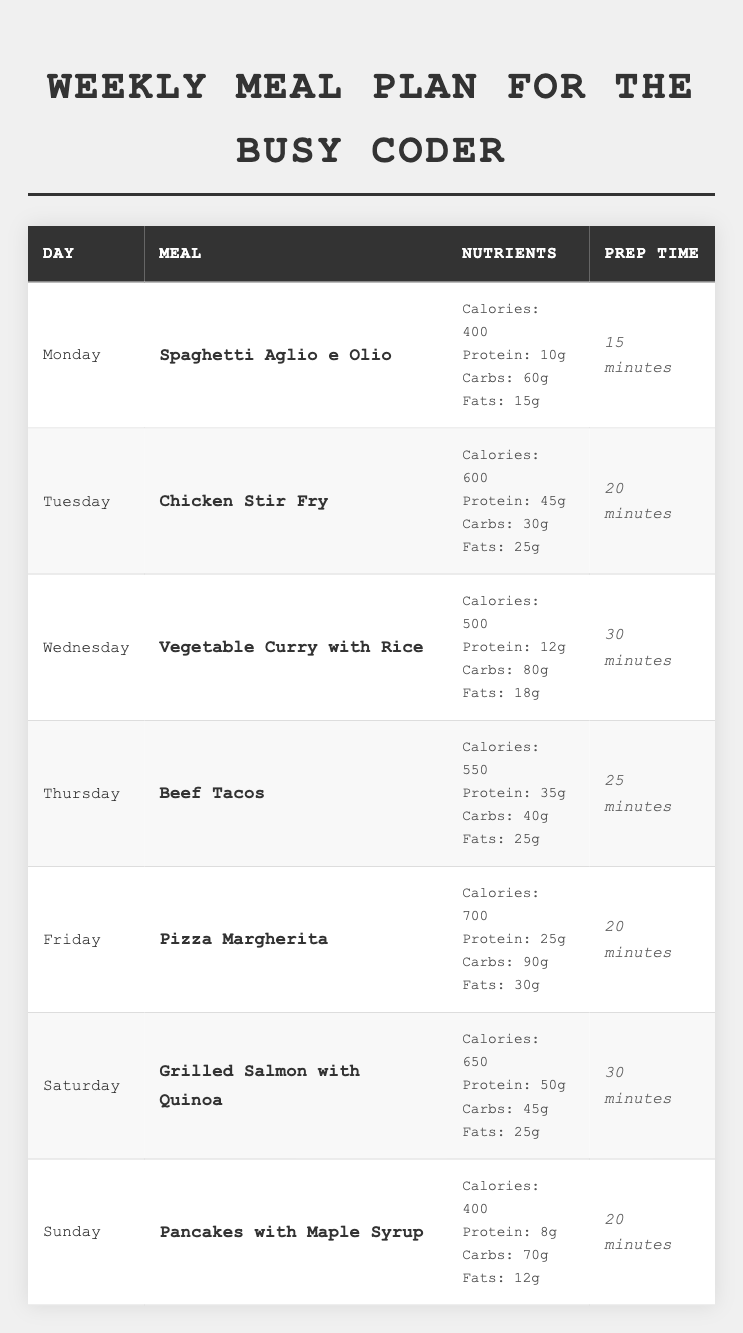What is the meal for Wednesday? Looking at the table, the meal listed for Wednesday is "Vegetable Curry with Rice".
Answer: Vegetable Curry with Rice Which meal has the highest amount of protein? By examining the protein values, "Chicken Stir Fry" has the highest protein content at 45g.
Answer: Chicken Stir Fry What are the total calories consumed from meals on Monday and Sunday? Adding the calories from Monday (400) and Sunday (400) gives a total of 400 + 400 = 800 calories.
Answer: 800 calories How long does it take to prepare the meal on Friday? The table indicates that the prep time for the meal on Friday, "Pizza Margherita," is 20 minutes.
Answer: 20 minutes Is the total carb content for Saturday more than 50 grams? The carb content for Saturday's meal "Grilled Salmon with Quinoa" is 45g, which is not more than 50g.
Answer: No What is the average calorie content of all meals for the week? The total calories for the week are 400 + 600 + 500 + 550 + 700 + 650 + 400 = 3900. Dividing by 7 meals gives an average of 3900 / 7 = 557.14 calories.
Answer: 557.14 calories On which day is the meal with the highest carbs served? The meal on Friday, "Pizza Margherita," has the highest carbs at 90g.
Answer: Friday What is the difference in protein content between the meal on Tuesday and Thursday? The protein content on Tuesday (45g) minus that on Thursday (35g) is 45 - 35 = 10g.
Answer: 10g Which meal takes the longest to prepare? By checking the prep times, "Vegetable Curry with Rice" on Wednesday takes the longest at 30 minutes.
Answer: Vegetable Curry with Rice Is the sum of fats on Monday and Wednesday less than 35 grams? The fats for Monday (15g) and Wednesday (18g) total 15 + 18 = 33g, which is less than 35g.
Answer: Yes 